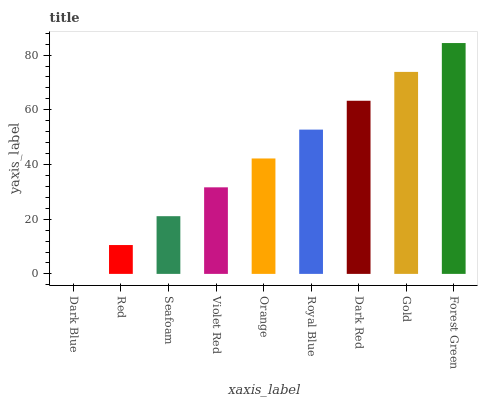Is Dark Blue the minimum?
Answer yes or no. Yes. Is Forest Green the maximum?
Answer yes or no. Yes. Is Red the minimum?
Answer yes or no. No. Is Red the maximum?
Answer yes or no. No. Is Red greater than Dark Blue?
Answer yes or no. Yes. Is Dark Blue less than Red?
Answer yes or no. Yes. Is Dark Blue greater than Red?
Answer yes or no. No. Is Red less than Dark Blue?
Answer yes or no. No. Is Orange the high median?
Answer yes or no. Yes. Is Orange the low median?
Answer yes or no. Yes. Is Gold the high median?
Answer yes or no. No. Is Forest Green the low median?
Answer yes or no. No. 